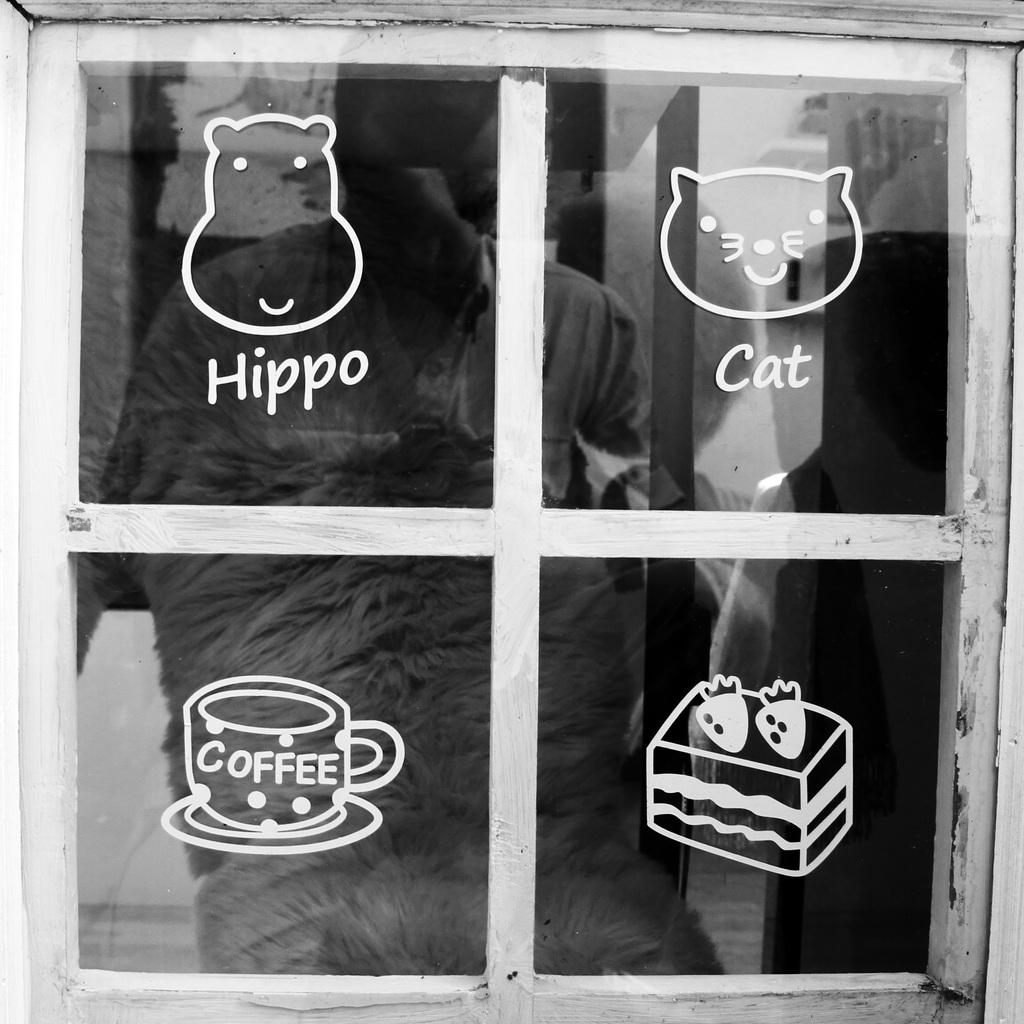What can be seen in the image related to a source of light or view? There is a window in the image. What is present on the window? There are drawings and words written on the window. Can you describe the reflection in the window? A person is visible in the reflection of the window. What is the profit margin of the drawings on the window? There is no information about profit margins in the image, as it focuses on the drawings and words written on the window. 